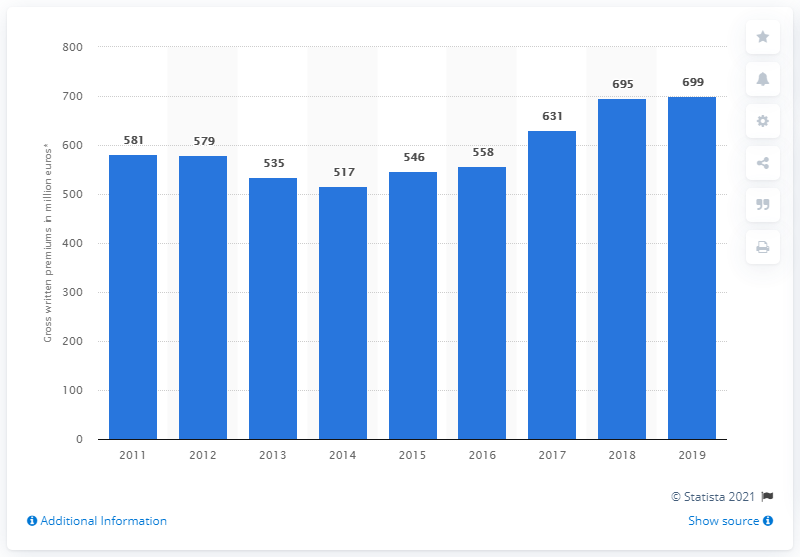Indicate a few pertinent items in this graphic. The value of life insurance premiums written in Slovenia in 2019 was 699. 